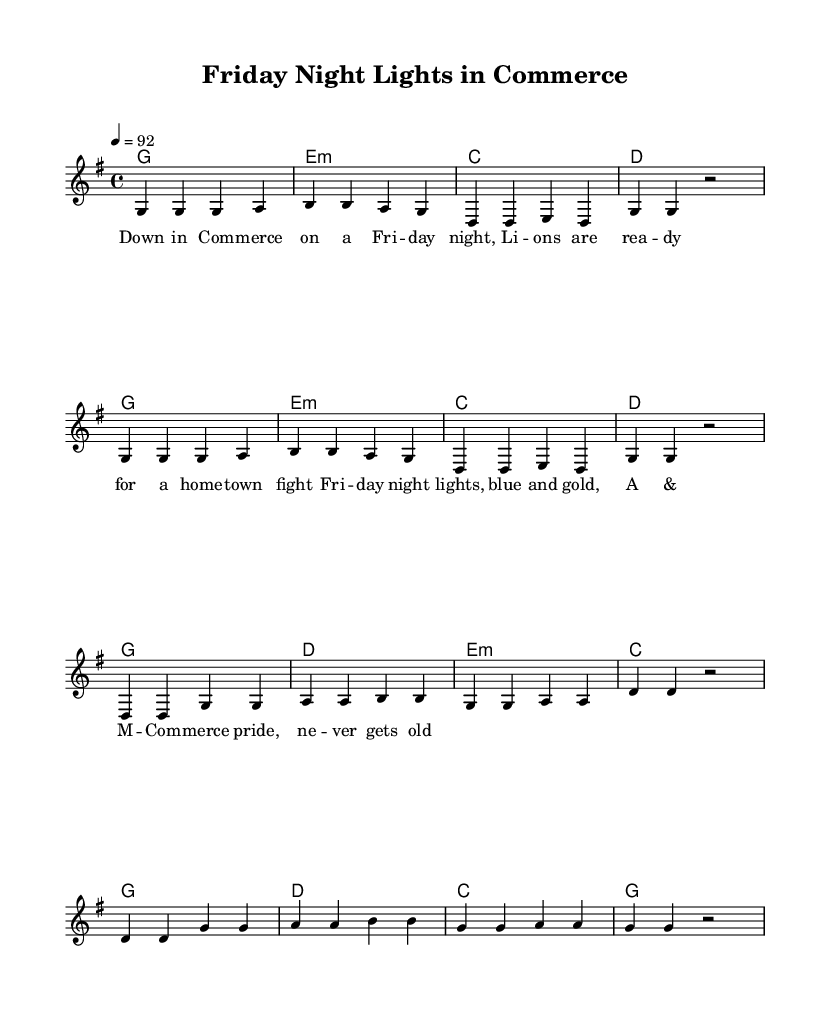What is the key signature of this music? The key signature is G major, which has one sharp (F#). This is identified at the beginning of the sheet music where the key signature is marked.
Answer: G major What is the time signature of this music? The time signature is 4/4, which indicates four beats per measure. This is indicated at the beginning of the sheet music as well.
Answer: 4/4 What is the tempo marking for this piece? The tempo marking is quarter note equals 92, which guides the performer on how fast to play the piece. This is indicated at the beginning of the music.
Answer: 92 How many measures are there in the verse section? The verse section consists of 4 measures, and this can be counted from the notation provided under the melody.
Answer: 4 What is the last chord of the chorus? The last chord of the chorus is G major, which can be identified by looking at the harmonies for the chorus section.
Answer: G What lyrical theme is evident in the song? The lyrical theme revolves around small-town pride and community spirit, evident from the lyrics about Friday night lights and college pride. This theme can be inferred from the content of the lyrics.
Answer: Small-town pride Which college is referenced in the lyrics? The college referenced in the lyrics is Texas A&M University - Commerce, which can be recognized from the lyrics explicitly mentioning A&M Commerce.
Answer: Texas A&M Commerce 